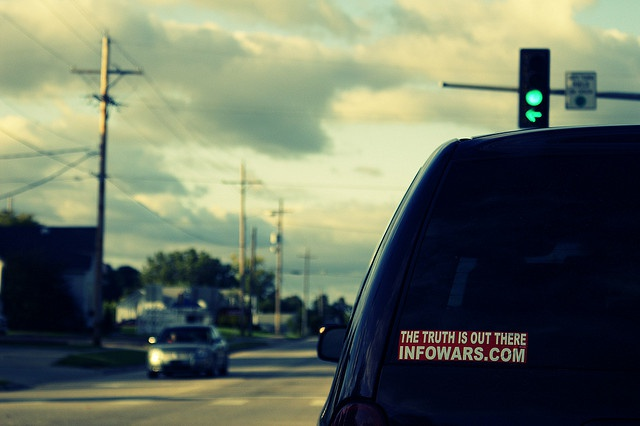Describe the objects in this image and their specific colors. I can see car in khaki, black, navy, maroon, and darkgray tones, car in khaki, black, navy, blue, and teal tones, and traffic light in khaki, black, lightgreen, teal, and darkgray tones in this image. 